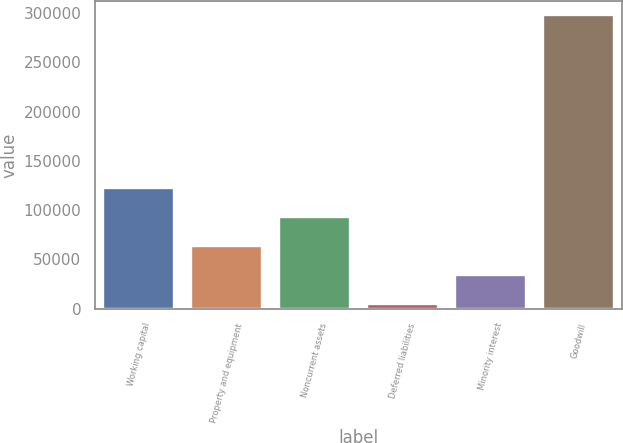Convert chart. <chart><loc_0><loc_0><loc_500><loc_500><bar_chart><fcel>Working capital<fcel>Property and equipment<fcel>Noncurrent assets<fcel>Deferred liabilities<fcel>Minority interest<fcel>Goodwill<nl><fcel>121977<fcel>63511.6<fcel>92744.4<fcel>5046<fcel>34278.8<fcel>297374<nl></chart> 